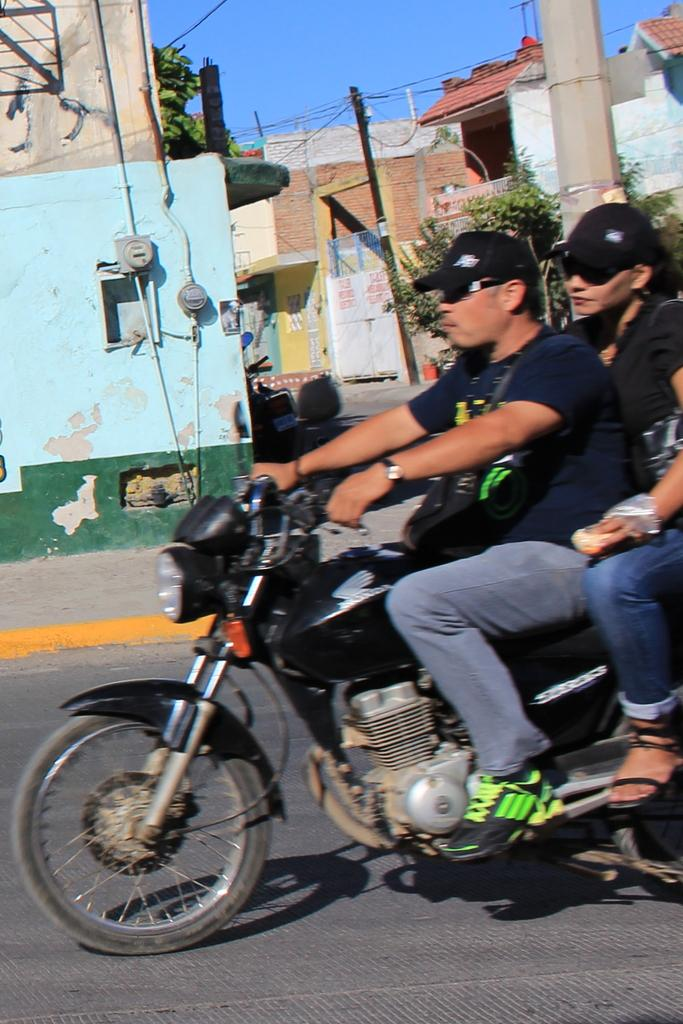How many people are in the image? There are two people in the image, a man and a woman. What are they doing in the image? They are on a bike. Where are they located in the image? They are on a path. What can be seen in the background of the image? There are buildings, trees, and the sky visible in the background of the image. What type of statement is being made by the carriage in the image? There is no carriage present in the image, so it is not possible to answer that question. 